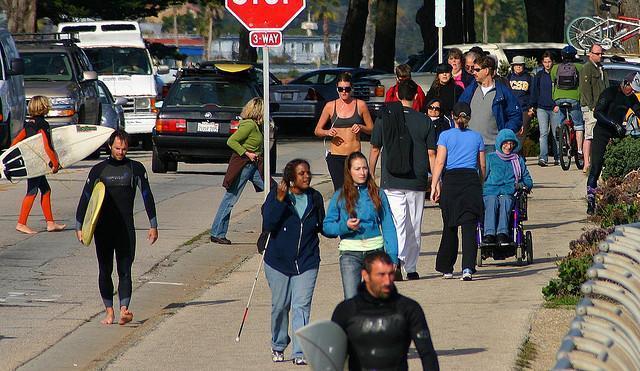How many cars are in the picture?
Give a very brief answer. 3. How many surfboards are in the picture?
Give a very brief answer. 2. How many people can be seen?
Give a very brief answer. 11. How many trucks are in the photo?
Give a very brief answer. 3. How many giraffes are laying down?
Give a very brief answer. 0. 